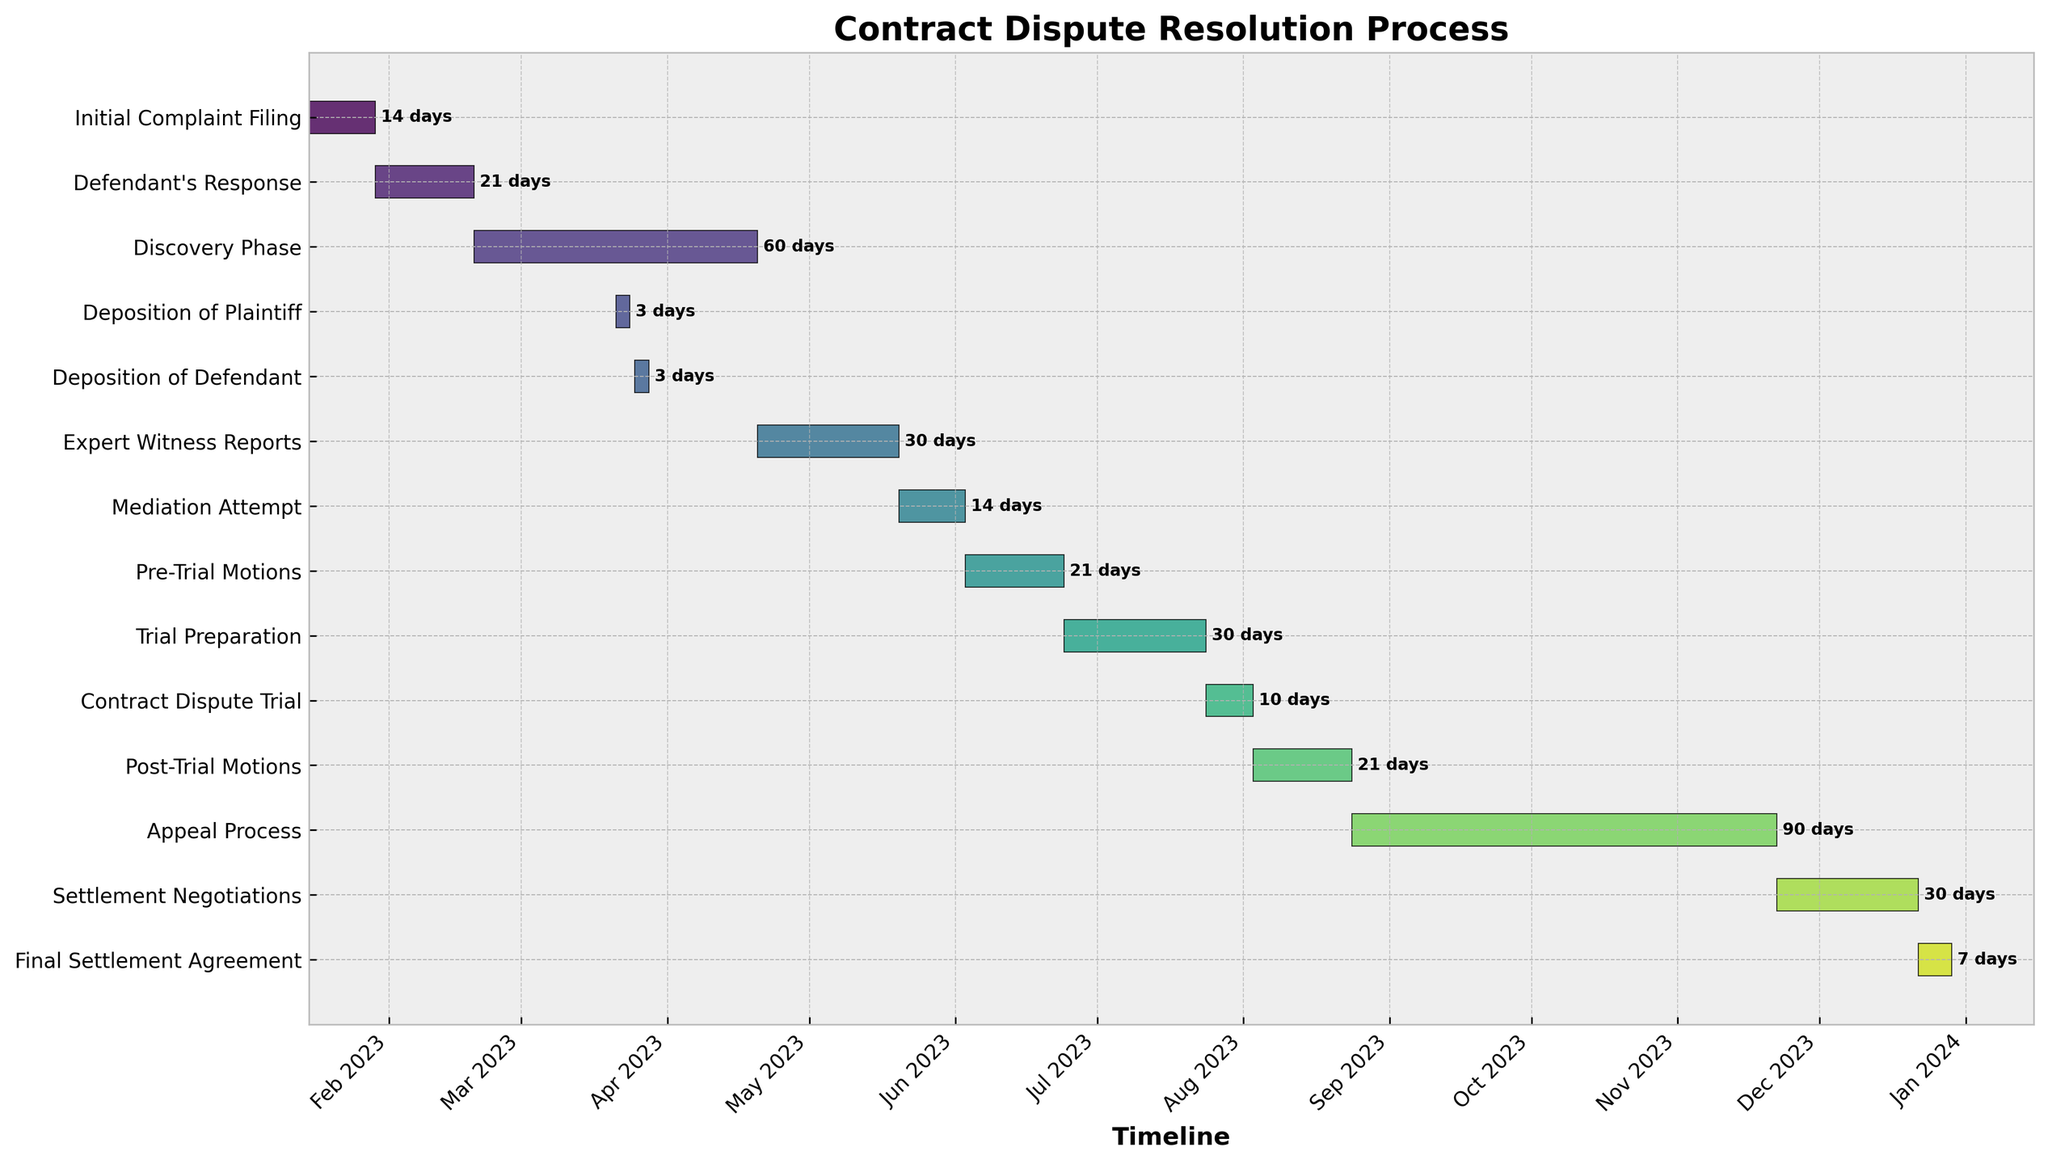Which stage of the contract dispute resolution process lasted the longest? The longest stage can be identified by the duration shown next to each bar. The Appeal Process lasted 90 days, which is the longest duration among all stages.
Answer: Appeal Process What is the overall time span from the Initial Complaint Filing to the Final Settlement Agreement? To find the overall time span, we note the start date of the Initial Complaint Filing and the end date of the Final Settlement Agreement. Initial Complaint Filing starts on 2023-01-15, and Final Settlement Agreement ends on 2023-12-29. Calculating the difference: (End Date - Start Date) = 2023-12-29 - 2023-01-15 = 348 days.
Answer: 348 days Which stage follows the Trial Preparation period? The stage following the Trial Preparation period can be observed by the sequence of tasks in the figure. Contract Dispute Trial follows immediately after the Trial Preparation period.
Answer: Contract Dispute Trial How many tasks had a duration of exactly 21 days? To find this, we count the tasks with a duration of 21 days based on the duration labels next to each task. Defendant's Response, Pre-Trial Motions, and Post-Trial Motions each lasted 21 days.
Answer: 3 tasks What is the duration of the Discovery Phase relative to the duration of the Mediation Attempt? The duration of the Discovery Phase is 60 days, and the Mediation Attempt is 14 days. Calculating the relative duration: (Duration of Discovery Phase / Duration of Mediation Attempt) = 60/14 ≈ 4.29.
Answer: ~4.29 times longer Which stages overlap in the month of March 2023? Overlaps can be identified by observing the horizontal bars on the timeline. Discovery Phase, Deposition of Plaintiff, and Deposition of Defendant all have bars that span into March 2023.
Answer: Discovery Phase, Deposition of Plaintiff, Deposition of Defendant Compare the duration of the Expert Witness Reports and the final Settlement Negotiations stages. Which one is longer, and by how many days? The Expert Witness Reports lasted 30 days, and the Settlement Negotiations lasted 30 days. Since both durations are equal, the difference is 0 days.
Answer: Both are 30 days, difference: 0 days During which time span does the Appeal Process occur? The Appeal Process starts on 2023-08-24 and ends after 90 days. Calculating the end date: Start Date + Duration = 2023-08-24 + 90 days = 2023-11-22. Therefore, the time span is from 2023-08-24 to 2023-11-22.
Answer: 2023-08-24 to 2023-11-22 